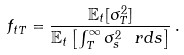<formula> <loc_0><loc_0><loc_500><loc_500>f _ { t T } = \frac { \mathbb { E } _ { t } [ \sigma _ { T } ^ { 2 } ] } { \mathbb { E } _ { t } \left [ \int _ { T } ^ { \infty } \sigma _ { s } ^ { 2 } \, \ r d s \right ] } \, .</formula> 